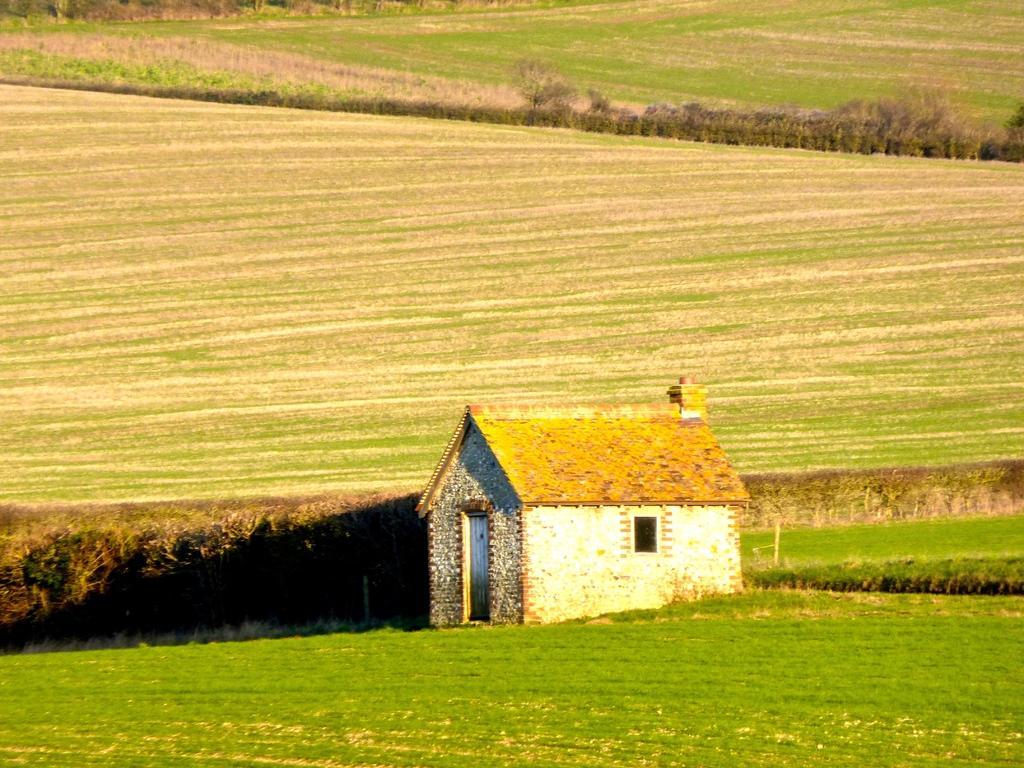What type of structure is visible in the image? There is a house in the image. What can be seen in the background of the image? There is grass and plants in the background of the image. What color are the plants and grass in the image? The plants and grass are green in color. What type of button can be seen on the title of the birthday cake in the image? There is no button or birthday cake present in the image; it features a house with green plants and grass in the background. 